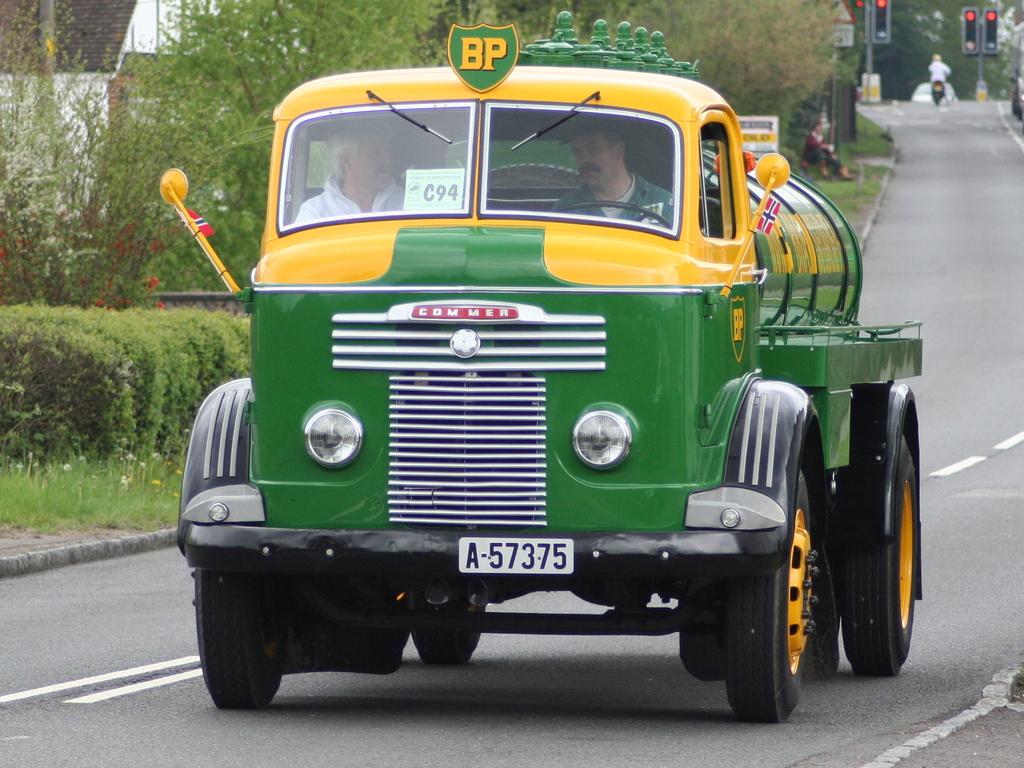What is the license plate?
Provide a short and direct response. A-57375. What are the letters on top of the truck?
Give a very brief answer. Bp. 